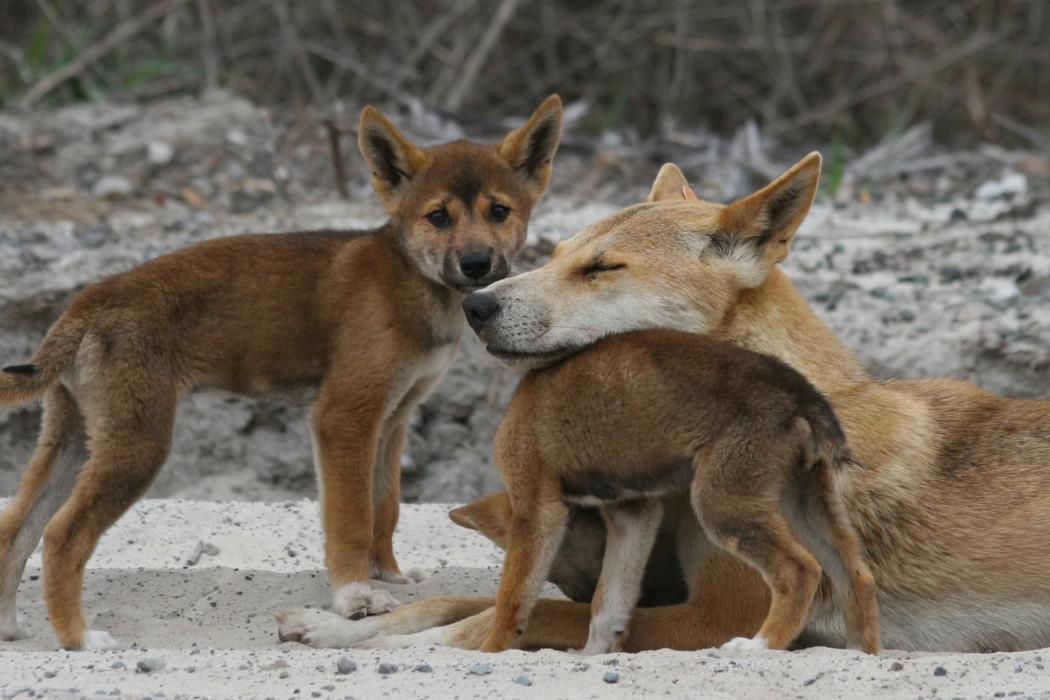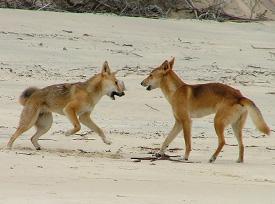The first image is the image on the left, the second image is the image on the right. Assess this claim about the two images: "One image includes a dingo moving across the sand, and the other image features an adult dingo with its head upon the body of a young dingo.". Correct or not? Answer yes or no. Yes. The first image is the image on the left, the second image is the image on the right. Given the left and right images, does the statement "The right image contains two wild dogs." hold true? Answer yes or no. Yes. 